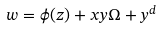Convert formula to latex. <formula><loc_0><loc_0><loc_500><loc_500>w = \phi ( z ) + x y \Omega + y ^ { d }</formula> 